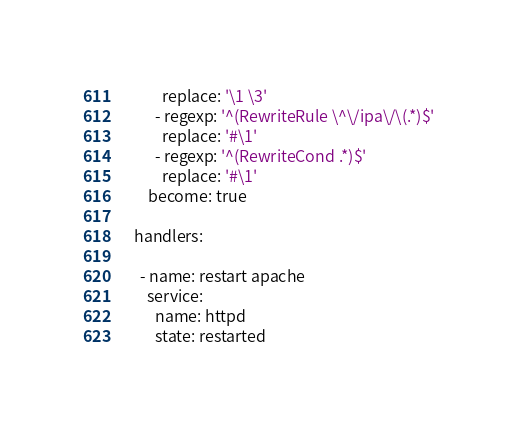Convert code to text. <code><loc_0><loc_0><loc_500><loc_500><_YAML_>          replace: '\1 \3'
        - regexp: '^(RewriteRule \^\/ipa\/\(.*)$'
          replace: '#\1'
        - regexp: '^(RewriteCond .*)$'
          replace: '#\1'
      become: true

  handlers:

    - name: restart apache
      service:
        name: httpd
        state: restarted
</code> 